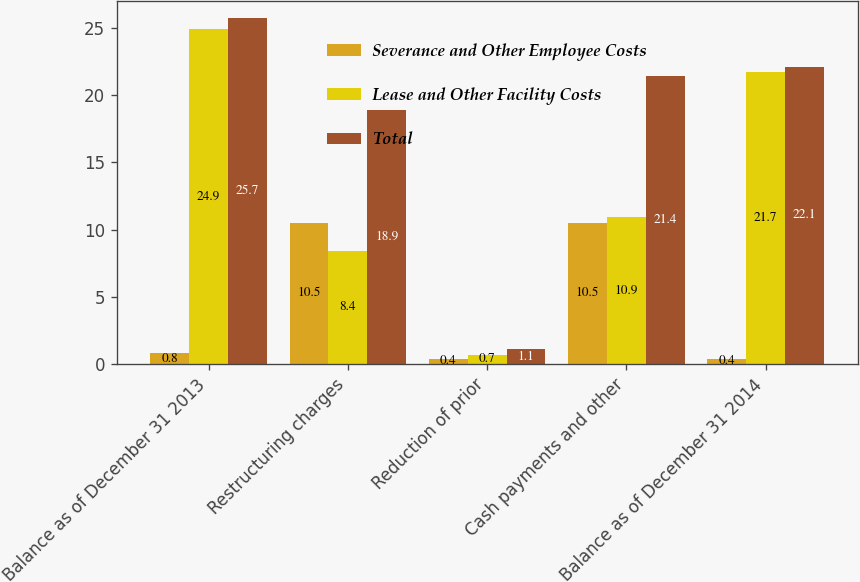<chart> <loc_0><loc_0><loc_500><loc_500><stacked_bar_chart><ecel><fcel>Balance as of December 31 2013<fcel>Restructuring charges<fcel>Reduction of prior<fcel>Cash payments and other<fcel>Balance as of December 31 2014<nl><fcel>Severance and Other Employee Costs<fcel>0.8<fcel>10.5<fcel>0.4<fcel>10.5<fcel>0.4<nl><fcel>Lease and Other Facility Costs<fcel>24.9<fcel>8.4<fcel>0.7<fcel>10.9<fcel>21.7<nl><fcel>Total<fcel>25.7<fcel>18.9<fcel>1.1<fcel>21.4<fcel>22.1<nl></chart> 